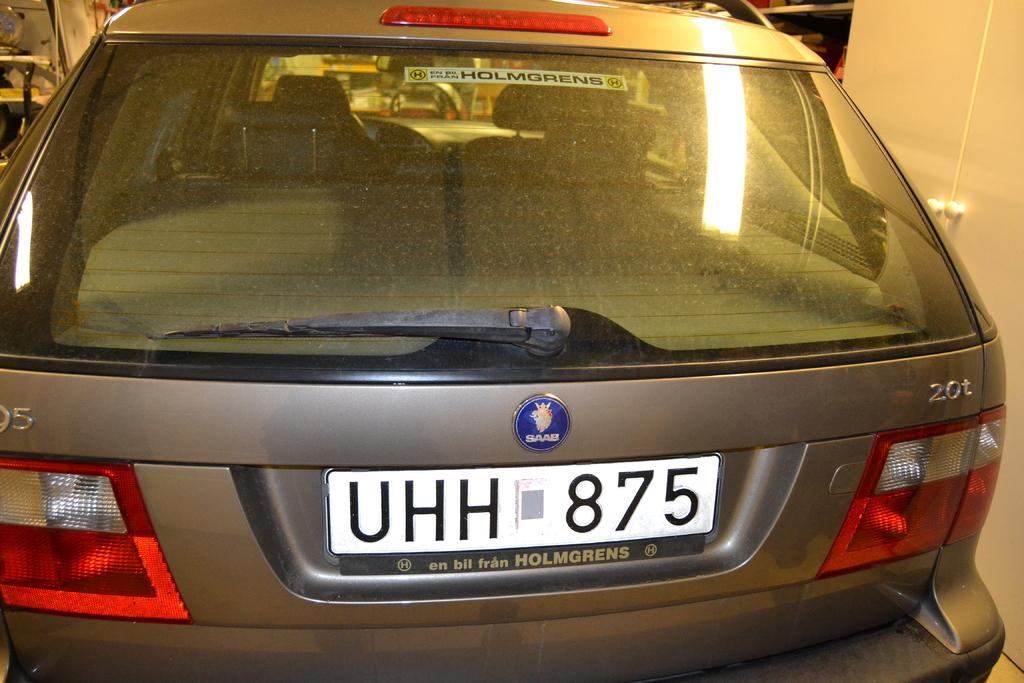Provide a one-sentence caption for the provided image. The back of a brownish silver colored Saab autombile parked in a garage. 